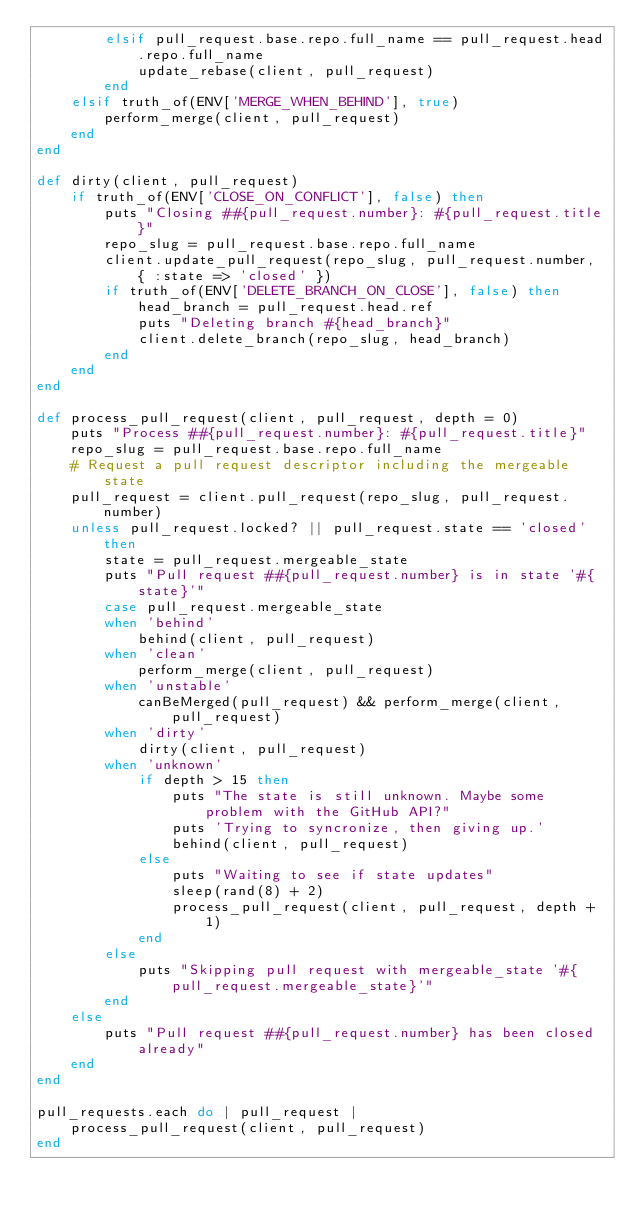Convert code to text. <code><loc_0><loc_0><loc_500><loc_500><_Ruby_>        elsif pull_request.base.repo.full_name == pull_request.head.repo.full_name
            update_rebase(client, pull_request)
        end
    elsif truth_of(ENV['MERGE_WHEN_BEHIND'], true)
        perform_merge(client, pull_request)
    end
end

def dirty(client, pull_request)
    if truth_of(ENV['CLOSE_ON_CONFLICT'], false) then
        puts "Closing ##{pull_request.number}: #{pull_request.title}"
        repo_slug = pull_request.base.repo.full_name
        client.update_pull_request(repo_slug, pull_request.number, { :state => 'closed' })
        if truth_of(ENV['DELETE_BRANCH_ON_CLOSE'], false) then
            head_branch = pull_request.head.ref
            puts "Deleting branch #{head_branch}"
            client.delete_branch(repo_slug, head_branch)
        end
    end
end

def process_pull_request(client, pull_request, depth = 0)
    puts "Process ##{pull_request.number}: #{pull_request.title}"
    repo_slug = pull_request.base.repo.full_name
    # Request a pull request descriptor including the mergeable state
    pull_request = client.pull_request(repo_slug, pull_request.number)
    unless pull_request.locked? || pull_request.state == 'closed' then
        state = pull_request.mergeable_state
        puts "Pull request ##{pull_request.number} is in state '#{state}'"
        case pull_request.mergeable_state
        when 'behind'
            behind(client, pull_request)
        when 'clean'
            perform_merge(client, pull_request)
        when 'unstable'
            canBeMerged(pull_request) && perform_merge(client, pull_request)
        when 'dirty'
            dirty(client, pull_request)
        when 'unknown'
            if depth > 15 then
                puts "The state is still unknown. Maybe some problem with the GitHub API?"
                puts 'Trying to syncronize, then giving up.'
                behind(client, pull_request)
            else
                puts "Waiting to see if state updates"
                sleep(rand(8) + 2)
                process_pull_request(client, pull_request, depth + 1)
            end
        else
            puts "Skipping pull request with mergeable_state '#{pull_request.mergeable_state}'"
        end
    else
        puts "Pull request ##{pull_request.number} has been closed already"
    end
end

pull_requests.each do | pull_request |
    process_pull_request(client, pull_request)
end
</code> 